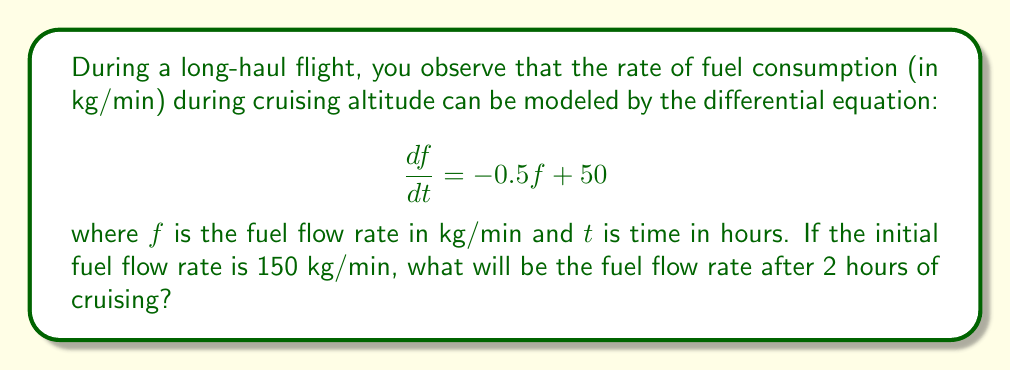Help me with this question. Let's solve this step-by-step:

1) We have a first-order linear differential equation:
   $$\frac{df}{dt} = -0.5f + 50$$

2) The general solution for this type of equation is:
   $$f(t) = ce^{-0.5t} + 100$$
   where $c$ is a constant to be determined by the initial condition.

3) We're given the initial condition: $f(0) = 150$. Let's use this:
   $$150 = ce^{-0.5(0)} + 100$$
   $$150 = c + 100$$
   $$c = 50$$

4) Now we have the particular solution:
   $$f(t) = 50e^{-0.5t} + 100$$

5) We want to find $f(2)$, the fuel flow rate after 2 hours:
   $$f(2) = 50e^{-0.5(2)} + 100$$
   $$f(2) = 50e^{-1} + 100$$
   $$f(2) = 50(0.3679) + 100$$
   $$f(2) = 18.395 + 100 = 118.395$$

6) Rounding to two decimal places:
   $$f(2) \approx 118.40 \text{ kg/min}$$
Answer: 118.40 kg/min 